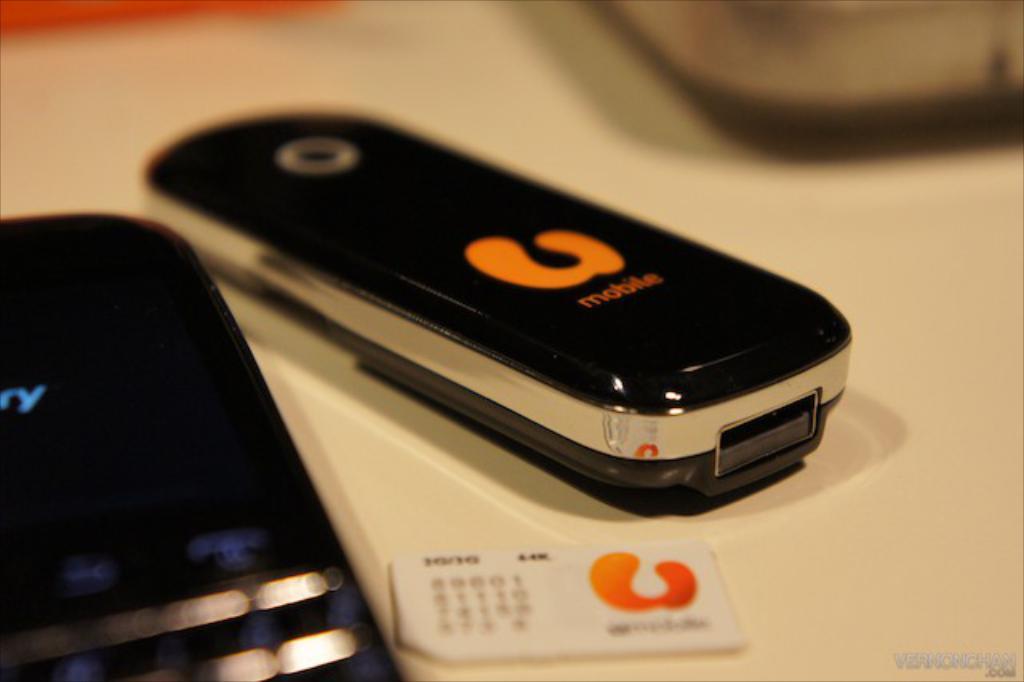What website is listed in the lower right hand corner of the picture?
Provide a short and direct response. Vernonchan.com. 